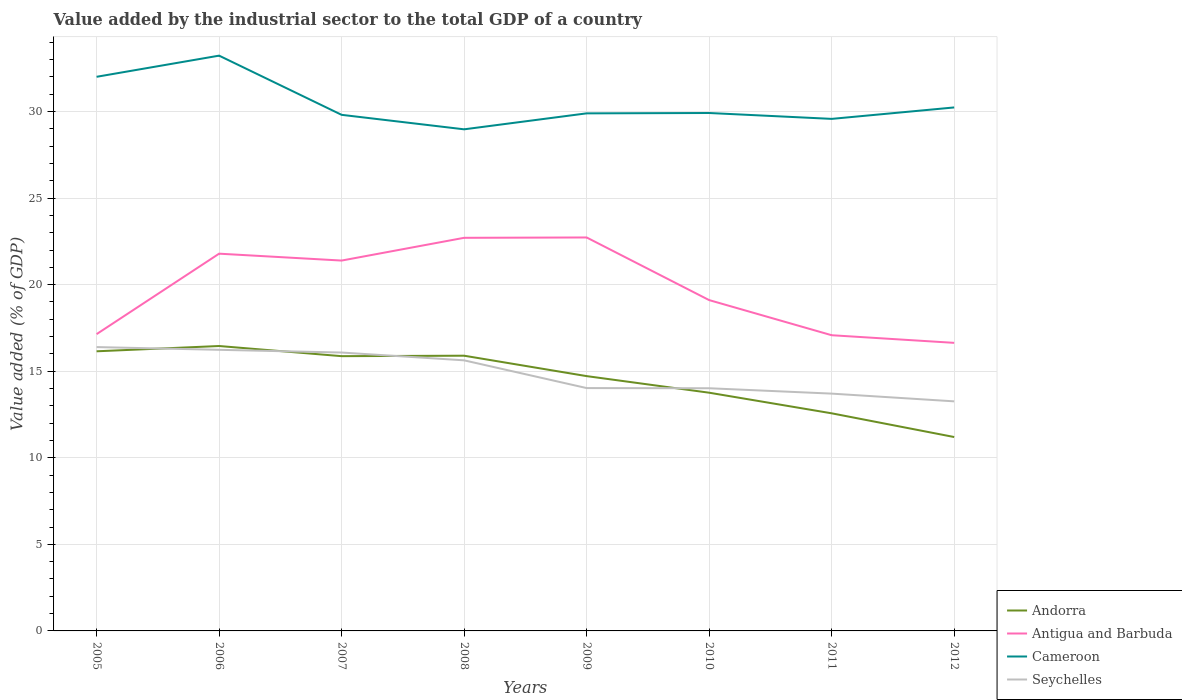Across all years, what is the maximum value added by the industrial sector to the total GDP in Antigua and Barbuda?
Make the answer very short. 16.64. What is the total value added by the industrial sector to the total GDP in Seychelles in the graph?
Provide a succinct answer. 0.31. What is the difference between the highest and the second highest value added by the industrial sector to the total GDP in Andorra?
Make the answer very short. 5.26. How many lines are there?
Give a very brief answer. 4. What is the difference between two consecutive major ticks on the Y-axis?
Ensure brevity in your answer.  5. Are the values on the major ticks of Y-axis written in scientific E-notation?
Keep it short and to the point. No. Does the graph contain grids?
Give a very brief answer. Yes. Where does the legend appear in the graph?
Offer a terse response. Bottom right. How are the legend labels stacked?
Keep it short and to the point. Vertical. What is the title of the graph?
Ensure brevity in your answer.  Value added by the industrial sector to the total GDP of a country. Does "Tuvalu" appear as one of the legend labels in the graph?
Give a very brief answer. No. What is the label or title of the Y-axis?
Your answer should be very brief. Value added (% of GDP). What is the Value added (% of GDP) in Andorra in 2005?
Ensure brevity in your answer.  16.15. What is the Value added (% of GDP) of Antigua and Barbuda in 2005?
Make the answer very short. 17.14. What is the Value added (% of GDP) of Cameroon in 2005?
Make the answer very short. 32.01. What is the Value added (% of GDP) of Seychelles in 2005?
Ensure brevity in your answer.  16.4. What is the Value added (% of GDP) in Andorra in 2006?
Offer a terse response. 16.46. What is the Value added (% of GDP) in Antigua and Barbuda in 2006?
Your answer should be compact. 21.79. What is the Value added (% of GDP) in Cameroon in 2006?
Your answer should be compact. 33.23. What is the Value added (% of GDP) of Seychelles in 2006?
Offer a terse response. 16.24. What is the Value added (% of GDP) of Andorra in 2007?
Provide a succinct answer. 15.87. What is the Value added (% of GDP) in Antigua and Barbuda in 2007?
Offer a terse response. 21.39. What is the Value added (% of GDP) in Cameroon in 2007?
Offer a terse response. 29.81. What is the Value added (% of GDP) in Seychelles in 2007?
Give a very brief answer. 16.08. What is the Value added (% of GDP) in Andorra in 2008?
Offer a terse response. 15.9. What is the Value added (% of GDP) of Antigua and Barbuda in 2008?
Give a very brief answer. 22.71. What is the Value added (% of GDP) of Cameroon in 2008?
Keep it short and to the point. 28.97. What is the Value added (% of GDP) in Seychelles in 2008?
Your answer should be very brief. 15.63. What is the Value added (% of GDP) in Andorra in 2009?
Offer a terse response. 14.72. What is the Value added (% of GDP) in Antigua and Barbuda in 2009?
Offer a very short reply. 22.73. What is the Value added (% of GDP) in Cameroon in 2009?
Offer a very short reply. 29.9. What is the Value added (% of GDP) in Seychelles in 2009?
Give a very brief answer. 14.03. What is the Value added (% of GDP) of Andorra in 2010?
Your answer should be very brief. 13.76. What is the Value added (% of GDP) in Antigua and Barbuda in 2010?
Your answer should be compact. 19.11. What is the Value added (% of GDP) in Cameroon in 2010?
Keep it short and to the point. 29.92. What is the Value added (% of GDP) of Seychelles in 2010?
Ensure brevity in your answer.  14.02. What is the Value added (% of GDP) in Andorra in 2011?
Provide a succinct answer. 12.57. What is the Value added (% of GDP) of Antigua and Barbuda in 2011?
Your answer should be very brief. 17.08. What is the Value added (% of GDP) in Cameroon in 2011?
Keep it short and to the point. 29.58. What is the Value added (% of GDP) of Seychelles in 2011?
Offer a terse response. 13.71. What is the Value added (% of GDP) of Andorra in 2012?
Give a very brief answer. 11.2. What is the Value added (% of GDP) of Antigua and Barbuda in 2012?
Make the answer very short. 16.64. What is the Value added (% of GDP) of Cameroon in 2012?
Your answer should be compact. 30.24. What is the Value added (% of GDP) of Seychelles in 2012?
Make the answer very short. 13.26. Across all years, what is the maximum Value added (% of GDP) in Andorra?
Provide a succinct answer. 16.46. Across all years, what is the maximum Value added (% of GDP) of Antigua and Barbuda?
Offer a very short reply. 22.73. Across all years, what is the maximum Value added (% of GDP) in Cameroon?
Provide a succinct answer. 33.23. Across all years, what is the maximum Value added (% of GDP) of Seychelles?
Offer a very short reply. 16.4. Across all years, what is the minimum Value added (% of GDP) in Andorra?
Your response must be concise. 11.2. Across all years, what is the minimum Value added (% of GDP) of Antigua and Barbuda?
Offer a very short reply. 16.64. Across all years, what is the minimum Value added (% of GDP) in Cameroon?
Offer a terse response. 28.97. Across all years, what is the minimum Value added (% of GDP) of Seychelles?
Ensure brevity in your answer.  13.26. What is the total Value added (% of GDP) of Andorra in the graph?
Your answer should be very brief. 116.63. What is the total Value added (% of GDP) of Antigua and Barbuda in the graph?
Provide a succinct answer. 158.59. What is the total Value added (% of GDP) of Cameroon in the graph?
Ensure brevity in your answer.  243.65. What is the total Value added (% of GDP) in Seychelles in the graph?
Your answer should be compact. 119.36. What is the difference between the Value added (% of GDP) of Andorra in 2005 and that in 2006?
Your answer should be very brief. -0.3. What is the difference between the Value added (% of GDP) in Antigua and Barbuda in 2005 and that in 2006?
Make the answer very short. -4.65. What is the difference between the Value added (% of GDP) in Cameroon in 2005 and that in 2006?
Offer a terse response. -1.22. What is the difference between the Value added (% of GDP) in Seychelles in 2005 and that in 2006?
Make the answer very short. 0.16. What is the difference between the Value added (% of GDP) in Andorra in 2005 and that in 2007?
Provide a succinct answer. 0.28. What is the difference between the Value added (% of GDP) in Antigua and Barbuda in 2005 and that in 2007?
Your answer should be compact. -4.25. What is the difference between the Value added (% of GDP) in Cameroon in 2005 and that in 2007?
Make the answer very short. 2.2. What is the difference between the Value added (% of GDP) in Seychelles in 2005 and that in 2007?
Offer a terse response. 0.32. What is the difference between the Value added (% of GDP) of Andorra in 2005 and that in 2008?
Provide a succinct answer. 0.25. What is the difference between the Value added (% of GDP) in Antigua and Barbuda in 2005 and that in 2008?
Give a very brief answer. -5.56. What is the difference between the Value added (% of GDP) of Cameroon in 2005 and that in 2008?
Make the answer very short. 3.03. What is the difference between the Value added (% of GDP) in Seychelles in 2005 and that in 2008?
Your answer should be very brief. 0.77. What is the difference between the Value added (% of GDP) in Andorra in 2005 and that in 2009?
Keep it short and to the point. 1.43. What is the difference between the Value added (% of GDP) of Antigua and Barbuda in 2005 and that in 2009?
Keep it short and to the point. -5.58. What is the difference between the Value added (% of GDP) of Cameroon in 2005 and that in 2009?
Your answer should be compact. 2.11. What is the difference between the Value added (% of GDP) of Seychelles in 2005 and that in 2009?
Keep it short and to the point. 2.37. What is the difference between the Value added (% of GDP) of Andorra in 2005 and that in 2010?
Provide a short and direct response. 2.39. What is the difference between the Value added (% of GDP) in Antigua and Barbuda in 2005 and that in 2010?
Your answer should be compact. -1.97. What is the difference between the Value added (% of GDP) of Cameroon in 2005 and that in 2010?
Your answer should be compact. 2.09. What is the difference between the Value added (% of GDP) of Seychelles in 2005 and that in 2010?
Give a very brief answer. 2.38. What is the difference between the Value added (% of GDP) of Andorra in 2005 and that in 2011?
Provide a short and direct response. 3.58. What is the difference between the Value added (% of GDP) in Antigua and Barbuda in 2005 and that in 2011?
Provide a succinct answer. 0.06. What is the difference between the Value added (% of GDP) of Cameroon in 2005 and that in 2011?
Your answer should be compact. 2.43. What is the difference between the Value added (% of GDP) of Seychelles in 2005 and that in 2011?
Ensure brevity in your answer.  2.69. What is the difference between the Value added (% of GDP) in Andorra in 2005 and that in 2012?
Ensure brevity in your answer.  4.95. What is the difference between the Value added (% of GDP) of Antigua and Barbuda in 2005 and that in 2012?
Give a very brief answer. 0.5. What is the difference between the Value added (% of GDP) of Cameroon in 2005 and that in 2012?
Your answer should be compact. 1.77. What is the difference between the Value added (% of GDP) of Seychelles in 2005 and that in 2012?
Your response must be concise. 3.14. What is the difference between the Value added (% of GDP) in Andorra in 2006 and that in 2007?
Offer a very short reply. 0.59. What is the difference between the Value added (% of GDP) of Antigua and Barbuda in 2006 and that in 2007?
Provide a succinct answer. 0.4. What is the difference between the Value added (% of GDP) of Cameroon in 2006 and that in 2007?
Offer a terse response. 3.42. What is the difference between the Value added (% of GDP) of Seychelles in 2006 and that in 2007?
Make the answer very short. 0.16. What is the difference between the Value added (% of GDP) in Andorra in 2006 and that in 2008?
Your answer should be very brief. 0.56. What is the difference between the Value added (% of GDP) of Antigua and Barbuda in 2006 and that in 2008?
Make the answer very short. -0.92. What is the difference between the Value added (% of GDP) of Cameroon in 2006 and that in 2008?
Make the answer very short. 4.26. What is the difference between the Value added (% of GDP) of Seychelles in 2006 and that in 2008?
Keep it short and to the point. 0.61. What is the difference between the Value added (% of GDP) of Andorra in 2006 and that in 2009?
Your response must be concise. 1.74. What is the difference between the Value added (% of GDP) in Antigua and Barbuda in 2006 and that in 2009?
Give a very brief answer. -0.94. What is the difference between the Value added (% of GDP) of Cameroon in 2006 and that in 2009?
Give a very brief answer. 3.33. What is the difference between the Value added (% of GDP) of Seychelles in 2006 and that in 2009?
Provide a succinct answer. 2.21. What is the difference between the Value added (% of GDP) of Andorra in 2006 and that in 2010?
Your response must be concise. 2.7. What is the difference between the Value added (% of GDP) of Antigua and Barbuda in 2006 and that in 2010?
Give a very brief answer. 2.68. What is the difference between the Value added (% of GDP) of Cameroon in 2006 and that in 2010?
Keep it short and to the point. 3.31. What is the difference between the Value added (% of GDP) of Seychelles in 2006 and that in 2010?
Provide a succinct answer. 2.22. What is the difference between the Value added (% of GDP) of Andorra in 2006 and that in 2011?
Ensure brevity in your answer.  3.89. What is the difference between the Value added (% of GDP) in Antigua and Barbuda in 2006 and that in 2011?
Provide a succinct answer. 4.71. What is the difference between the Value added (% of GDP) of Cameroon in 2006 and that in 2011?
Provide a short and direct response. 3.65. What is the difference between the Value added (% of GDP) of Seychelles in 2006 and that in 2011?
Your response must be concise. 2.53. What is the difference between the Value added (% of GDP) of Andorra in 2006 and that in 2012?
Provide a succinct answer. 5.26. What is the difference between the Value added (% of GDP) in Antigua and Barbuda in 2006 and that in 2012?
Offer a very short reply. 5.15. What is the difference between the Value added (% of GDP) in Cameroon in 2006 and that in 2012?
Offer a terse response. 2.99. What is the difference between the Value added (% of GDP) in Seychelles in 2006 and that in 2012?
Give a very brief answer. 2.98. What is the difference between the Value added (% of GDP) of Andorra in 2007 and that in 2008?
Offer a very short reply. -0.03. What is the difference between the Value added (% of GDP) in Antigua and Barbuda in 2007 and that in 2008?
Your answer should be compact. -1.31. What is the difference between the Value added (% of GDP) of Cameroon in 2007 and that in 2008?
Provide a succinct answer. 0.84. What is the difference between the Value added (% of GDP) of Seychelles in 2007 and that in 2008?
Offer a very short reply. 0.45. What is the difference between the Value added (% of GDP) in Andorra in 2007 and that in 2009?
Offer a terse response. 1.15. What is the difference between the Value added (% of GDP) in Antigua and Barbuda in 2007 and that in 2009?
Make the answer very short. -1.33. What is the difference between the Value added (% of GDP) in Cameroon in 2007 and that in 2009?
Your answer should be compact. -0.09. What is the difference between the Value added (% of GDP) in Seychelles in 2007 and that in 2009?
Provide a succinct answer. 2.05. What is the difference between the Value added (% of GDP) of Andorra in 2007 and that in 2010?
Ensure brevity in your answer.  2.11. What is the difference between the Value added (% of GDP) in Antigua and Barbuda in 2007 and that in 2010?
Provide a succinct answer. 2.28. What is the difference between the Value added (% of GDP) of Cameroon in 2007 and that in 2010?
Offer a very short reply. -0.11. What is the difference between the Value added (% of GDP) of Seychelles in 2007 and that in 2010?
Keep it short and to the point. 2.06. What is the difference between the Value added (% of GDP) of Andorra in 2007 and that in 2011?
Your answer should be compact. 3.3. What is the difference between the Value added (% of GDP) of Antigua and Barbuda in 2007 and that in 2011?
Make the answer very short. 4.31. What is the difference between the Value added (% of GDP) of Cameroon in 2007 and that in 2011?
Offer a terse response. 0.23. What is the difference between the Value added (% of GDP) of Seychelles in 2007 and that in 2011?
Provide a short and direct response. 2.37. What is the difference between the Value added (% of GDP) in Andorra in 2007 and that in 2012?
Give a very brief answer. 4.67. What is the difference between the Value added (% of GDP) of Antigua and Barbuda in 2007 and that in 2012?
Your answer should be compact. 4.75. What is the difference between the Value added (% of GDP) of Cameroon in 2007 and that in 2012?
Provide a short and direct response. -0.43. What is the difference between the Value added (% of GDP) of Seychelles in 2007 and that in 2012?
Give a very brief answer. 2.82. What is the difference between the Value added (% of GDP) in Andorra in 2008 and that in 2009?
Make the answer very short. 1.18. What is the difference between the Value added (% of GDP) in Antigua and Barbuda in 2008 and that in 2009?
Keep it short and to the point. -0.02. What is the difference between the Value added (% of GDP) of Cameroon in 2008 and that in 2009?
Offer a very short reply. -0.92. What is the difference between the Value added (% of GDP) in Seychelles in 2008 and that in 2009?
Make the answer very short. 1.6. What is the difference between the Value added (% of GDP) of Andorra in 2008 and that in 2010?
Give a very brief answer. 2.14. What is the difference between the Value added (% of GDP) in Antigua and Barbuda in 2008 and that in 2010?
Provide a succinct answer. 3.6. What is the difference between the Value added (% of GDP) of Cameroon in 2008 and that in 2010?
Provide a succinct answer. -0.94. What is the difference between the Value added (% of GDP) in Seychelles in 2008 and that in 2010?
Ensure brevity in your answer.  1.61. What is the difference between the Value added (% of GDP) in Andorra in 2008 and that in 2011?
Your response must be concise. 3.33. What is the difference between the Value added (% of GDP) in Antigua and Barbuda in 2008 and that in 2011?
Your answer should be compact. 5.63. What is the difference between the Value added (% of GDP) in Cameroon in 2008 and that in 2011?
Provide a short and direct response. -0.6. What is the difference between the Value added (% of GDP) in Seychelles in 2008 and that in 2011?
Offer a very short reply. 1.92. What is the difference between the Value added (% of GDP) of Andorra in 2008 and that in 2012?
Offer a very short reply. 4.7. What is the difference between the Value added (% of GDP) in Antigua and Barbuda in 2008 and that in 2012?
Provide a short and direct response. 6.07. What is the difference between the Value added (% of GDP) in Cameroon in 2008 and that in 2012?
Your response must be concise. -1.26. What is the difference between the Value added (% of GDP) of Seychelles in 2008 and that in 2012?
Make the answer very short. 2.37. What is the difference between the Value added (% of GDP) of Andorra in 2009 and that in 2010?
Your answer should be very brief. 0.96. What is the difference between the Value added (% of GDP) in Antigua and Barbuda in 2009 and that in 2010?
Make the answer very short. 3.62. What is the difference between the Value added (% of GDP) of Cameroon in 2009 and that in 2010?
Your response must be concise. -0.02. What is the difference between the Value added (% of GDP) in Seychelles in 2009 and that in 2010?
Offer a very short reply. 0.01. What is the difference between the Value added (% of GDP) of Andorra in 2009 and that in 2011?
Your answer should be very brief. 2.15. What is the difference between the Value added (% of GDP) of Antigua and Barbuda in 2009 and that in 2011?
Make the answer very short. 5.65. What is the difference between the Value added (% of GDP) in Cameroon in 2009 and that in 2011?
Make the answer very short. 0.32. What is the difference between the Value added (% of GDP) of Seychelles in 2009 and that in 2011?
Your response must be concise. 0.32. What is the difference between the Value added (% of GDP) in Andorra in 2009 and that in 2012?
Ensure brevity in your answer.  3.52. What is the difference between the Value added (% of GDP) in Antigua and Barbuda in 2009 and that in 2012?
Your answer should be compact. 6.09. What is the difference between the Value added (% of GDP) of Cameroon in 2009 and that in 2012?
Keep it short and to the point. -0.34. What is the difference between the Value added (% of GDP) of Seychelles in 2009 and that in 2012?
Provide a short and direct response. 0.77. What is the difference between the Value added (% of GDP) of Andorra in 2010 and that in 2011?
Provide a short and direct response. 1.19. What is the difference between the Value added (% of GDP) of Antigua and Barbuda in 2010 and that in 2011?
Offer a very short reply. 2.03. What is the difference between the Value added (% of GDP) of Cameroon in 2010 and that in 2011?
Provide a short and direct response. 0.34. What is the difference between the Value added (% of GDP) of Seychelles in 2010 and that in 2011?
Offer a terse response. 0.31. What is the difference between the Value added (% of GDP) in Andorra in 2010 and that in 2012?
Your answer should be very brief. 2.56. What is the difference between the Value added (% of GDP) in Antigua and Barbuda in 2010 and that in 2012?
Keep it short and to the point. 2.47. What is the difference between the Value added (% of GDP) in Cameroon in 2010 and that in 2012?
Make the answer very short. -0.32. What is the difference between the Value added (% of GDP) of Seychelles in 2010 and that in 2012?
Provide a short and direct response. 0.76. What is the difference between the Value added (% of GDP) of Andorra in 2011 and that in 2012?
Make the answer very short. 1.37. What is the difference between the Value added (% of GDP) in Antigua and Barbuda in 2011 and that in 2012?
Ensure brevity in your answer.  0.44. What is the difference between the Value added (% of GDP) of Cameroon in 2011 and that in 2012?
Provide a short and direct response. -0.66. What is the difference between the Value added (% of GDP) in Seychelles in 2011 and that in 2012?
Your answer should be very brief. 0.45. What is the difference between the Value added (% of GDP) of Andorra in 2005 and the Value added (% of GDP) of Antigua and Barbuda in 2006?
Keep it short and to the point. -5.64. What is the difference between the Value added (% of GDP) of Andorra in 2005 and the Value added (% of GDP) of Cameroon in 2006?
Your response must be concise. -17.08. What is the difference between the Value added (% of GDP) of Andorra in 2005 and the Value added (% of GDP) of Seychelles in 2006?
Your response must be concise. -0.09. What is the difference between the Value added (% of GDP) of Antigua and Barbuda in 2005 and the Value added (% of GDP) of Cameroon in 2006?
Ensure brevity in your answer.  -16.09. What is the difference between the Value added (% of GDP) of Antigua and Barbuda in 2005 and the Value added (% of GDP) of Seychelles in 2006?
Keep it short and to the point. 0.91. What is the difference between the Value added (% of GDP) in Cameroon in 2005 and the Value added (% of GDP) in Seychelles in 2006?
Offer a terse response. 15.77. What is the difference between the Value added (% of GDP) in Andorra in 2005 and the Value added (% of GDP) in Antigua and Barbuda in 2007?
Provide a short and direct response. -5.24. What is the difference between the Value added (% of GDP) of Andorra in 2005 and the Value added (% of GDP) of Cameroon in 2007?
Your response must be concise. -13.66. What is the difference between the Value added (% of GDP) of Andorra in 2005 and the Value added (% of GDP) of Seychelles in 2007?
Keep it short and to the point. 0.07. What is the difference between the Value added (% of GDP) of Antigua and Barbuda in 2005 and the Value added (% of GDP) of Cameroon in 2007?
Ensure brevity in your answer.  -12.67. What is the difference between the Value added (% of GDP) in Antigua and Barbuda in 2005 and the Value added (% of GDP) in Seychelles in 2007?
Your response must be concise. 1.06. What is the difference between the Value added (% of GDP) in Cameroon in 2005 and the Value added (% of GDP) in Seychelles in 2007?
Offer a very short reply. 15.93. What is the difference between the Value added (% of GDP) of Andorra in 2005 and the Value added (% of GDP) of Antigua and Barbuda in 2008?
Your answer should be compact. -6.56. What is the difference between the Value added (% of GDP) of Andorra in 2005 and the Value added (% of GDP) of Cameroon in 2008?
Offer a terse response. -12.82. What is the difference between the Value added (% of GDP) of Andorra in 2005 and the Value added (% of GDP) of Seychelles in 2008?
Offer a terse response. 0.52. What is the difference between the Value added (% of GDP) in Antigua and Barbuda in 2005 and the Value added (% of GDP) in Cameroon in 2008?
Offer a terse response. -11.83. What is the difference between the Value added (% of GDP) of Antigua and Barbuda in 2005 and the Value added (% of GDP) of Seychelles in 2008?
Make the answer very short. 1.51. What is the difference between the Value added (% of GDP) of Cameroon in 2005 and the Value added (% of GDP) of Seychelles in 2008?
Your response must be concise. 16.38. What is the difference between the Value added (% of GDP) of Andorra in 2005 and the Value added (% of GDP) of Antigua and Barbuda in 2009?
Your answer should be very brief. -6.57. What is the difference between the Value added (% of GDP) of Andorra in 2005 and the Value added (% of GDP) of Cameroon in 2009?
Keep it short and to the point. -13.74. What is the difference between the Value added (% of GDP) in Andorra in 2005 and the Value added (% of GDP) in Seychelles in 2009?
Give a very brief answer. 2.12. What is the difference between the Value added (% of GDP) in Antigua and Barbuda in 2005 and the Value added (% of GDP) in Cameroon in 2009?
Ensure brevity in your answer.  -12.75. What is the difference between the Value added (% of GDP) of Antigua and Barbuda in 2005 and the Value added (% of GDP) of Seychelles in 2009?
Provide a succinct answer. 3.12. What is the difference between the Value added (% of GDP) of Cameroon in 2005 and the Value added (% of GDP) of Seychelles in 2009?
Give a very brief answer. 17.98. What is the difference between the Value added (% of GDP) of Andorra in 2005 and the Value added (% of GDP) of Antigua and Barbuda in 2010?
Make the answer very short. -2.96. What is the difference between the Value added (% of GDP) of Andorra in 2005 and the Value added (% of GDP) of Cameroon in 2010?
Ensure brevity in your answer.  -13.76. What is the difference between the Value added (% of GDP) of Andorra in 2005 and the Value added (% of GDP) of Seychelles in 2010?
Ensure brevity in your answer.  2.13. What is the difference between the Value added (% of GDP) in Antigua and Barbuda in 2005 and the Value added (% of GDP) in Cameroon in 2010?
Your answer should be compact. -12.77. What is the difference between the Value added (% of GDP) of Antigua and Barbuda in 2005 and the Value added (% of GDP) of Seychelles in 2010?
Ensure brevity in your answer.  3.13. What is the difference between the Value added (% of GDP) in Cameroon in 2005 and the Value added (% of GDP) in Seychelles in 2010?
Give a very brief answer. 17.99. What is the difference between the Value added (% of GDP) in Andorra in 2005 and the Value added (% of GDP) in Antigua and Barbuda in 2011?
Your answer should be compact. -0.93. What is the difference between the Value added (% of GDP) of Andorra in 2005 and the Value added (% of GDP) of Cameroon in 2011?
Offer a very short reply. -13.43. What is the difference between the Value added (% of GDP) of Andorra in 2005 and the Value added (% of GDP) of Seychelles in 2011?
Offer a terse response. 2.44. What is the difference between the Value added (% of GDP) in Antigua and Barbuda in 2005 and the Value added (% of GDP) in Cameroon in 2011?
Your response must be concise. -12.43. What is the difference between the Value added (% of GDP) in Antigua and Barbuda in 2005 and the Value added (% of GDP) in Seychelles in 2011?
Ensure brevity in your answer.  3.44. What is the difference between the Value added (% of GDP) in Cameroon in 2005 and the Value added (% of GDP) in Seychelles in 2011?
Give a very brief answer. 18.3. What is the difference between the Value added (% of GDP) in Andorra in 2005 and the Value added (% of GDP) in Antigua and Barbuda in 2012?
Offer a terse response. -0.49. What is the difference between the Value added (% of GDP) in Andorra in 2005 and the Value added (% of GDP) in Cameroon in 2012?
Offer a terse response. -14.09. What is the difference between the Value added (% of GDP) in Andorra in 2005 and the Value added (% of GDP) in Seychelles in 2012?
Make the answer very short. 2.89. What is the difference between the Value added (% of GDP) of Antigua and Barbuda in 2005 and the Value added (% of GDP) of Cameroon in 2012?
Provide a succinct answer. -13.09. What is the difference between the Value added (% of GDP) in Antigua and Barbuda in 2005 and the Value added (% of GDP) in Seychelles in 2012?
Give a very brief answer. 3.88. What is the difference between the Value added (% of GDP) of Cameroon in 2005 and the Value added (% of GDP) of Seychelles in 2012?
Your response must be concise. 18.75. What is the difference between the Value added (% of GDP) in Andorra in 2006 and the Value added (% of GDP) in Antigua and Barbuda in 2007?
Keep it short and to the point. -4.94. What is the difference between the Value added (% of GDP) in Andorra in 2006 and the Value added (% of GDP) in Cameroon in 2007?
Provide a succinct answer. -13.35. What is the difference between the Value added (% of GDP) in Andorra in 2006 and the Value added (% of GDP) in Seychelles in 2007?
Give a very brief answer. 0.38. What is the difference between the Value added (% of GDP) of Antigua and Barbuda in 2006 and the Value added (% of GDP) of Cameroon in 2007?
Provide a succinct answer. -8.02. What is the difference between the Value added (% of GDP) in Antigua and Barbuda in 2006 and the Value added (% of GDP) in Seychelles in 2007?
Keep it short and to the point. 5.71. What is the difference between the Value added (% of GDP) of Cameroon in 2006 and the Value added (% of GDP) of Seychelles in 2007?
Provide a short and direct response. 17.15. What is the difference between the Value added (% of GDP) in Andorra in 2006 and the Value added (% of GDP) in Antigua and Barbuda in 2008?
Keep it short and to the point. -6.25. What is the difference between the Value added (% of GDP) of Andorra in 2006 and the Value added (% of GDP) of Cameroon in 2008?
Your response must be concise. -12.52. What is the difference between the Value added (% of GDP) of Andorra in 2006 and the Value added (% of GDP) of Seychelles in 2008?
Your answer should be very brief. 0.83. What is the difference between the Value added (% of GDP) of Antigua and Barbuda in 2006 and the Value added (% of GDP) of Cameroon in 2008?
Your answer should be very brief. -7.18. What is the difference between the Value added (% of GDP) in Antigua and Barbuda in 2006 and the Value added (% of GDP) in Seychelles in 2008?
Ensure brevity in your answer.  6.16. What is the difference between the Value added (% of GDP) of Cameroon in 2006 and the Value added (% of GDP) of Seychelles in 2008?
Make the answer very short. 17.6. What is the difference between the Value added (% of GDP) in Andorra in 2006 and the Value added (% of GDP) in Antigua and Barbuda in 2009?
Your answer should be very brief. -6.27. What is the difference between the Value added (% of GDP) in Andorra in 2006 and the Value added (% of GDP) in Cameroon in 2009?
Give a very brief answer. -13.44. What is the difference between the Value added (% of GDP) of Andorra in 2006 and the Value added (% of GDP) of Seychelles in 2009?
Your answer should be compact. 2.43. What is the difference between the Value added (% of GDP) of Antigua and Barbuda in 2006 and the Value added (% of GDP) of Cameroon in 2009?
Offer a very short reply. -8.11. What is the difference between the Value added (% of GDP) in Antigua and Barbuda in 2006 and the Value added (% of GDP) in Seychelles in 2009?
Ensure brevity in your answer.  7.76. What is the difference between the Value added (% of GDP) in Cameroon in 2006 and the Value added (% of GDP) in Seychelles in 2009?
Your response must be concise. 19.2. What is the difference between the Value added (% of GDP) of Andorra in 2006 and the Value added (% of GDP) of Antigua and Barbuda in 2010?
Keep it short and to the point. -2.65. What is the difference between the Value added (% of GDP) in Andorra in 2006 and the Value added (% of GDP) in Cameroon in 2010?
Provide a short and direct response. -13.46. What is the difference between the Value added (% of GDP) in Andorra in 2006 and the Value added (% of GDP) in Seychelles in 2010?
Your response must be concise. 2.44. What is the difference between the Value added (% of GDP) of Antigua and Barbuda in 2006 and the Value added (% of GDP) of Cameroon in 2010?
Ensure brevity in your answer.  -8.13. What is the difference between the Value added (% of GDP) in Antigua and Barbuda in 2006 and the Value added (% of GDP) in Seychelles in 2010?
Keep it short and to the point. 7.77. What is the difference between the Value added (% of GDP) of Cameroon in 2006 and the Value added (% of GDP) of Seychelles in 2010?
Give a very brief answer. 19.21. What is the difference between the Value added (% of GDP) of Andorra in 2006 and the Value added (% of GDP) of Antigua and Barbuda in 2011?
Provide a succinct answer. -0.62. What is the difference between the Value added (% of GDP) in Andorra in 2006 and the Value added (% of GDP) in Cameroon in 2011?
Your response must be concise. -13.12. What is the difference between the Value added (% of GDP) of Andorra in 2006 and the Value added (% of GDP) of Seychelles in 2011?
Ensure brevity in your answer.  2.75. What is the difference between the Value added (% of GDP) in Antigua and Barbuda in 2006 and the Value added (% of GDP) in Cameroon in 2011?
Your answer should be compact. -7.79. What is the difference between the Value added (% of GDP) in Antigua and Barbuda in 2006 and the Value added (% of GDP) in Seychelles in 2011?
Provide a short and direct response. 8.08. What is the difference between the Value added (% of GDP) of Cameroon in 2006 and the Value added (% of GDP) of Seychelles in 2011?
Provide a succinct answer. 19.52. What is the difference between the Value added (% of GDP) in Andorra in 2006 and the Value added (% of GDP) in Antigua and Barbuda in 2012?
Offer a very short reply. -0.18. What is the difference between the Value added (% of GDP) of Andorra in 2006 and the Value added (% of GDP) of Cameroon in 2012?
Make the answer very short. -13.78. What is the difference between the Value added (% of GDP) in Andorra in 2006 and the Value added (% of GDP) in Seychelles in 2012?
Give a very brief answer. 3.2. What is the difference between the Value added (% of GDP) in Antigua and Barbuda in 2006 and the Value added (% of GDP) in Cameroon in 2012?
Give a very brief answer. -8.45. What is the difference between the Value added (% of GDP) of Antigua and Barbuda in 2006 and the Value added (% of GDP) of Seychelles in 2012?
Ensure brevity in your answer.  8.53. What is the difference between the Value added (% of GDP) in Cameroon in 2006 and the Value added (% of GDP) in Seychelles in 2012?
Keep it short and to the point. 19.97. What is the difference between the Value added (% of GDP) in Andorra in 2007 and the Value added (% of GDP) in Antigua and Barbuda in 2008?
Give a very brief answer. -6.84. What is the difference between the Value added (% of GDP) in Andorra in 2007 and the Value added (% of GDP) in Cameroon in 2008?
Provide a succinct answer. -13.1. What is the difference between the Value added (% of GDP) of Andorra in 2007 and the Value added (% of GDP) of Seychelles in 2008?
Make the answer very short. 0.24. What is the difference between the Value added (% of GDP) of Antigua and Barbuda in 2007 and the Value added (% of GDP) of Cameroon in 2008?
Your answer should be very brief. -7.58. What is the difference between the Value added (% of GDP) in Antigua and Barbuda in 2007 and the Value added (% of GDP) in Seychelles in 2008?
Ensure brevity in your answer.  5.76. What is the difference between the Value added (% of GDP) of Cameroon in 2007 and the Value added (% of GDP) of Seychelles in 2008?
Ensure brevity in your answer.  14.18. What is the difference between the Value added (% of GDP) of Andorra in 2007 and the Value added (% of GDP) of Antigua and Barbuda in 2009?
Offer a very short reply. -6.86. What is the difference between the Value added (% of GDP) in Andorra in 2007 and the Value added (% of GDP) in Cameroon in 2009?
Provide a short and direct response. -14.03. What is the difference between the Value added (% of GDP) of Andorra in 2007 and the Value added (% of GDP) of Seychelles in 2009?
Your answer should be very brief. 1.84. What is the difference between the Value added (% of GDP) of Antigua and Barbuda in 2007 and the Value added (% of GDP) of Cameroon in 2009?
Make the answer very short. -8.5. What is the difference between the Value added (% of GDP) of Antigua and Barbuda in 2007 and the Value added (% of GDP) of Seychelles in 2009?
Make the answer very short. 7.37. What is the difference between the Value added (% of GDP) in Cameroon in 2007 and the Value added (% of GDP) in Seychelles in 2009?
Keep it short and to the point. 15.78. What is the difference between the Value added (% of GDP) of Andorra in 2007 and the Value added (% of GDP) of Antigua and Barbuda in 2010?
Keep it short and to the point. -3.24. What is the difference between the Value added (% of GDP) of Andorra in 2007 and the Value added (% of GDP) of Cameroon in 2010?
Your answer should be very brief. -14.05. What is the difference between the Value added (% of GDP) of Andorra in 2007 and the Value added (% of GDP) of Seychelles in 2010?
Offer a very short reply. 1.85. What is the difference between the Value added (% of GDP) of Antigua and Barbuda in 2007 and the Value added (% of GDP) of Cameroon in 2010?
Give a very brief answer. -8.52. What is the difference between the Value added (% of GDP) in Antigua and Barbuda in 2007 and the Value added (% of GDP) in Seychelles in 2010?
Give a very brief answer. 7.38. What is the difference between the Value added (% of GDP) of Cameroon in 2007 and the Value added (% of GDP) of Seychelles in 2010?
Offer a terse response. 15.79. What is the difference between the Value added (% of GDP) of Andorra in 2007 and the Value added (% of GDP) of Antigua and Barbuda in 2011?
Provide a succinct answer. -1.21. What is the difference between the Value added (% of GDP) in Andorra in 2007 and the Value added (% of GDP) in Cameroon in 2011?
Offer a terse response. -13.71. What is the difference between the Value added (% of GDP) in Andorra in 2007 and the Value added (% of GDP) in Seychelles in 2011?
Your response must be concise. 2.16. What is the difference between the Value added (% of GDP) in Antigua and Barbuda in 2007 and the Value added (% of GDP) in Cameroon in 2011?
Offer a terse response. -8.18. What is the difference between the Value added (% of GDP) in Antigua and Barbuda in 2007 and the Value added (% of GDP) in Seychelles in 2011?
Your response must be concise. 7.69. What is the difference between the Value added (% of GDP) of Cameroon in 2007 and the Value added (% of GDP) of Seychelles in 2011?
Offer a very short reply. 16.1. What is the difference between the Value added (% of GDP) in Andorra in 2007 and the Value added (% of GDP) in Antigua and Barbuda in 2012?
Keep it short and to the point. -0.77. What is the difference between the Value added (% of GDP) in Andorra in 2007 and the Value added (% of GDP) in Cameroon in 2012?
Your response must be concise. -14.37. What is the difference between the Value added (% of GDP) of Andorra in 2007 and the Value added (% of GDP) of Seychelles in 2012?
Offer a terse response. 2.61. What is the difference between the Value added (% of GDP) of Antigua and Barbuda in 2007 and the Value added (% of GDP) of Cameroon in 2012?
Your response must be concise. -8.85. What is the difference between the Value added (% of GDP) of Antigua and Barbuda in 2007 and the Value added (% of GDP) of Seychelles in 2012?
Give a very brief answer. 8.13. What is the difference between the Value added (% of GDP) of Cameroon in 2007 and the Value added (% of GDP) of Seychelles in 2012?
Provide a short and direct response. 16.55. What is the difference between the Value added (% of GDP) in Andorra in 2008 and the Value added (% of GDP) in Antigua and Barbuda in 2009?
Your answer should be compact. -6.83. What is the difference between the Value added (% of GDP) of Andorra in 2008 and the Value added (% of GDP) of Cameroon in 2009?
Give a very brief answer. -14. What is the difference between the Value added (% of GDP) in Andorra in 2008 and the Value added (% of GDP) in Seychelles in 2009?
Offer a terse response. 1.87. What is the difference between the Value added (% of GDP) of Antigua and Barbuda in 2008 and the Value added (% of GDP) of Cameroon in 2009?
Give a very brief answer. -7.19. What is the difference between the Value added (% of GDP) of Antigua and Barbuda in 2008 and the Value added (% of GDP) of Seychelles in 2009?
Keep it short and to the point. 8.68. What is the difference between the Value added (% of GDP) of Cameroon in 2008 and the Value added (% of GDP) of Seychelles in 2009?
Ensure brevity in your answer.  14.95. What is the difference between the Value added (% of GDP) of Andorra in 2008 and the Value added (% of GDP) of Antigua and Barbuda in 2010?
Your response must be concise. -3.21. What is the difference between the Value added (% of GDP) in Andorra in 2008 and the Value added (% of GDP) in Cameroon in 2010?
Ensure brevity in your answer.  -14.02. What is the difference between the Value added (% of GDP) in Andorra in 2008 and the Value added (% of GDP) in Seychelles in 2010?
Your response must be concise. 1.88. What is the difference between the Value added (% of GDP) of Antigua and Barbuda in 2008 and the Value added (% of GDP) of Cameroon in 2010?
Make the answer very short. -7.21. What is the difference between the Value added (% of GDP) in Antigua and Barbuda in 2008 and the Value added (% of GDP) in Seychelles in 2010?
Offer a very short reply. 8.69. What is the difference between the Value added (% of GDP) in Cameroon in 2008 and the Value added (% of GDP) in Seychelles in 2010?
Make the answer very short. 14.96. What is the difference between the Value added (% of GDP) of Andorra in 2008 and the Value added (% of GDP) of Antigua and Barbuda in 2011?
Your response must be concise. -1.18. What is the difference between the Value added (% of GDP) in Andorra in 2008 and the Value added (% of GDP) in Cameroon in 2011?
Ensure brevity in your answer.  -13.68. What is the difference between the Value added (% of GDP) in Andorra in 2008 and the Value added (% of GDP) in Seychelles in 2011?
Your response must be concise. 2.19. What is the difference between the Value added (% of GDP) of Antigua and Barbuda in 2008 and the Value added (% of GDP) of Cameroon in 2011?
Your answer should be compact. -6.87. What is the difference between the Value added (% of GDP) of Antigua and Barbuda in 2008 and the Value added (% of GDP) of Seychelles in 2011?
Keep it short and to the point. 9. What is the difference between the Value added (% of GDP) in Cameroon in 2008 and the Value added (% of GDP) in Seychelles in 2011?
Provide a succinct answer. 15.27. What is the difference between the Value added (% of GDP) of Andorra in 2008 and the Value added (% of GDP) of Antigua and Barbuda in 2012?
Your answer should be very brief. -0.74. What is the difference between the Value added (% of GDP) of Andorra in 2008 and the Value added (% of GDP) of Cameroon in 2012?
Give a very brief answer. -14.34. What is the difference between the Value added (% of GDP) in Andorra in 2008 and the Value added (% of GDP) in Seychelles in 2012?
Keep it short and to the point. 2.64. What is the difference between the Value added (% of GDP) of Antigua and Barbuda in 2008 and the Value added (% of GDP) of Cameroon in 2012?
Ensure brevity in your answer.  -7.53. What is the difference between the Value added (% of GDP) in Antigua and Barbuda in 2008 and the Value added (% of GDP) in Seychelles in 2012?
Keep it short and to the point. 9.45. What is the difference between the Value added (% of GDP) of Cameroon in 2008 and the Value added (% of GDP) of Seychelles in 2012?
Offer a very short reply. 15.71. What is the difference between the Value added (% of GDP) in Andorra in 2009 and the Value added (% of GDP) in Antigua and Barbuda in 2010?
Make the answer very short. -4.39. What is the difference between the Value added (% of GDP) of Andorra in 2009 and the Value added (% of GDP) of Cameroon in 2010?
Provide a short and direct response. -15.2. What is the difference between the Value added (% of GDP) of Andorra in 2009 and the Value added (% of GDP) of Seychelles in 2010?
Offer a terse response. 0.7. What is the difference between the Value added (% of GDP) of Antigua and Barbuda in 2009 and the Value added (% of GDP) of Cameroon in 2010?
Offer a terse response. -7.19. What is the difference between the Value added (% of GDP) in Antigua and Barbuda in 2009 and the Value added (% of GDP) in Seychelles in 2010?
Provide a short and direct response. 8.71. What is the difference between the Value added (% of GDP) of Cameroon in 2009 and the Value added (% of GDP) of Seychelles in 2010?
Provide a short and direct response. 15.88. What is the difference between the Value added (% of GDP) in Andorra in 2009 and the Value added (% of GDP) in Antigua and Barbuda in 2011?
Give a very brief answer. -2.36. What is the difference between the Value added (% of GDP) of Andorra in 2009 and the Value added (% of GDP) of Cameroon in 2011?
Offer a terse response. -14.86. What is the difference between the Value added (% of GDP) in Andorra in 2009 and the Value added (% of GDP) in Seychelles in 2011?
Your answer should be very brief. 1.01. What is the difference between the Value added (% of GDP) in Antigua and Barbuda in 2009 and the Value added (% of GDP) in Cameroon in 2011?
Provide a succinct answer. -6.85. What is the difference between the Value added (% of GDP) in Antigua and Barbuda in 2009 and the Value added (% of GDP) in Seychelles in 2011?
Keep it short and to the point. 9.02. What is the difference between the Value added (% of GDP) in Cameroon in 2009 and the Value added (% of GDP) in Seychelles in 2011?
Make the answer very short. 16.19. What is the difference between the Value added (% of GDP) in Andorra in 2009 and the Value added (% of GDP) in Antigua and Barbuda in 2012?
Provide a short and direct response. -1.92. What is the difference between the Value added (% of GDP) of Andorra in 2009 and the Value added (% of GDP) of Cameroon in 2012?
Provide a short and direct response. -15.52. What is the difference between the Value added (% of GDP) of Andorra in 2009 and the Value added (% of GDP) of Seychelles in 2012?
Keep it short and to the point. 1.46. What is the difference between the Value added (% of GDP) in Antigua and Barbuda in 2009 and the Value added (% of GDP) in Cameroon in 2012?
Your response must be concise. -7.51. What is the difference between the Value added (% of GDP) of Antigua and Barbuda in 2009 and the Value added (% of GDP) of Seychelles in 2012?
Provide a short and direct response. 9.47. What is the difference between the Value added (% of GDP) in Cameroon in 2009 and the Value added (% of GDP) in Seychelles in 2012?
Keep it short and to the point. 16.64. What is the difference between the Value added (% of GDP) in Andorra in 2010 and the Value added (% of GDP) in Antigua and Barbuda in 2011?
Make the answer very short. -3.32. What is the difference between the Value added (% of GDP) of Andorra in 2010 and the Value added (% of GDP) of Cameroon in 2011?
Your answer should be compact. -15.82. What is the difference between the Value added (% of GDP) of Andorra in 2010 and the Value added (% of GDP) of Seychelles in 2011?
Make the answer very short. 0.05. What is the difference between the Value added (% of GDP) of Antigua and Barbuda in 2010 and the Value added (% of GDP) of Cameroon in 2011?
Your answer should be compact. -10.47. What is the difference between the Value added (% of GDP) of Antigua and Barbuda in 2010 and the Value added (% of GDP) of Seychelles in 2011?
Make the answer very short. 5.4. What is the difference between the Value added (% of GDP) in Cameroon in 2010 and the Value added (% of GDP) in Seychelles in 2011?
Your answer should be compact. 16.21. What is the difference between the Value added (% of GDP) of Andorra in 2010 and the Value added (% of GDP) of Antigua and Barbuda in 2012?
Give a very brief answer. -2.88. What is the difference between the Value added (% of GDP) of Andorra in 2010 and the Value added (% of GDP) of Cameroon in 2012?
Your answer should be compact. -16.48. What is the difference between the Value added (% of GDP) in Andorra in 2010 and the Value added (% of GDP) in Seychelles in 2012?
Keep it short and to the point. 0.5. What is the difference between the Value added (% of GDP) in Antigua and Barbuda in 2010 and the Value added (% of GDP) in Cameroon in 2012?
Your response must be concise. -11.13. What is the difference between the Value added (% of GDP) of Antigua and Barbuda in 2010 and the Value added (% of GDP) of Seychelles in 2012?
Your answer should be very brief. 5.85. What is the difference between the Value added (% of GDP) of Cameroon in 2010 and the Value added (% of GDP) of Seychelles in 2012?
Keep it short and to the point. 16.66. What is the difference between the Value added (% of GDP) in Andorra in 2011 and the Value added (% of GDP) in Antigua and Barbuda in 2012?
Your answer should be very brief. -4.07. What is the difference between the Value added (% of GDP) of Andorra in 2011 and the Value added (% of GDP) of Cameroon in 2012?
Your answer should be very brief. -17.67. What is the difference between the Value added (% of GDP) of Andorra in 2011 and the Value added (% of GDP) of Seychelles in 2012?
Your answer should be compact. -0.69. What is the difference between the Value added (% of GDP) in Antigua and Barbuda in 2011 and the Value added (% of GDP) in Cameroon in 2012?
Your answer should be compact. -13.16. What is the difference between the Value added (% of GDP) of Antigua and Barbuda in 2011 and the Value added (% of GDP) of Seychelles in 2012?
Provide a succinct answer. 3.82. What is the difference between the Value added (% of GDP) of Cameroon in 2011 and the Value added (% of GDP) of Seychelles in 2012?
Make the answer very short. 16.32. What is the average Value added (% of GDP) in Andorra per year?
Provide a succinct answer. 14.58. What is the average Value added (% of GDP) in Antigua and Barbuda per year?
Your answer should be very brief. 19.82. What is the average Value added (% of GDP) in Cameroon per year?
Provide a short and direct response. 30.46. What is the average Value added (% of GDP) of Seychelles per year?
Your answer should be compact. 14.92. In the year 2005, what is the difference between the Value added (% of GDP) in Andorra and Value added (% of GDP) in Antigua and Barbuda?
Your response must be concise. -0.99. In the year 2005, what is the difference between the Value added (% of GDP) of Andorra and Value added (% of GDP) of Cameroon?
Offer a terse response. -15.86. In the year 2005, what is the difference between the Value added (% of GDP) in Andorra and Value added (% of GDP) in Seychelles?
Keep it short and to the point. -0.24. In the year 2005, what is the difference between the Value added (% of GDP) of Antigua and Barbuda and Value added (% of GDP) of Cameroon?
Provide a short and direct response. -14.86. In the year 2005, what is the difference between the Value added (% of GDP) in Antigua and Barbuda and Value added (% of GDP) in Seychelles?
Keep it short and to the point. 0.75. In the year 2005, what is the difference between the Value added (% of GDP) of Cameroon and Value added (% of GDP) of Seychelles?
Make the answer very short. 15.61. In the year 2006, what is the difference between the Value added (% of GDP) in Andorra and Value added (% of GDP) in Antigua and Barbuda?
Your answer should be very brief. -5.33. In the year 2006, what is the difference between the Value added (% of GDP) in Andorra and Value added (% of GDP) in Cameroon?
Provide a succinct answer. -16.77. In the year 2006, what is the difference between the Value added (% of GDP) of Andorra and Value added (% of GDP) of Seychelles?
Ensure brevity in your answer.  0.22. In the year 2006, what is the difference between the Value added (% of GDP) in Antigua and Barbuda and Value added (% of GDP) in Cameroon?
Offer a very short reply. -11.44. In the year 2006, what is the difference between the Value added (% of GDP) of Antigua and Barbuda and Value added (% of GDP) of Seychelles?
Make the answer very short. 5.55. In the year 2006, what is the difference between the Value added (% of GDP) of Cameroon and Value added (% of GDP) of Seychelles?
Keep it short and to the point. 16.99. In the year 2007, what is the difference between the Value added (% of GDP) in Andorra and Value added (% of GDP) in Antigua and Barbuda?
Your answer should be very brief. -5.52. In the year 2007, what is the difference between the Value added (% of GDP) of Andorra and Value added (% of GDP) of Cameroon?
Provide a short and direct response. -13.94. In the year 2007, what is the difference between the Value added (% of GDP) in Andorra and Value added (% of GDP) in Seychelles?
Offer a very short reply. -0.21. In the year 2007, what is the difference between the Value added (% of GDP) in Antigua and Barbuda and Value added (% of GDP) in Cameroon?
Your response must be concise. -8.42. In the year 2007, what is the difference between the Value added (% of GDP) in Antigua and Barbuda and Value added (% of GDP) in Seychelles?
Offer a terse response. 5.31. In the year 2007, what is the difference between the Value added (% of GDP) in Cameroon and Value added (% of GDP) in Seychelles?
Your answer should be compact. 13.73. In the year 2008, what is the difference between the Value added (% of GDP) of Andorra and Value added (% of GDP) of Antigua and Barbuda?
Your response must be concise. -6.81. In the year 2008, what is the difference between the Value added (% of GDP) in Andorra and Value added (% of GDP) in Cameroon?
Make the answer very short. -13.08. In the year 2008, what is the difference between the Value added (% of GDP) in Andorra and Value added (% of GDP) in Seychelles?
Ensure brevity in your answer.  0.27. In the year 2008, what is the difference between the Value added (% of GDP) of Antigua and Barbuda and Value added (% of GDP) of Cameroon?
Ensure brevity in your answer.  -6.27. In the year 2008, what is the difference between the Value added (% of GDP) in Antigua and Barbuda and Value added (% of GDP) in Seychelles?
Provide a succinct answer. 7.08. In the year 2008, what is the difference between the Value added (% of GDP) of Cameroon and Value added (% of GDP) of Seychelles?
Offer a terse response. 13.34. In the year 2009, what is the difference between the Value added (% of GDP) in Andorra and Value added (% of GDP) in Antigua and Barbuda?
Offer a very short reply. -8.01. In the year 2009, what is the difference between the Value added (% of GDP) in Andorra and Value added (% of GDP) in Cameroon?
Offer a terse response. -15.18. In the year 2009, what is the difference between the Value added (% of GDP) of Andorra and Value added (% of GDP) of Seychelles?
Your response must be concise. 0.69. In the year 2009, what is the difference between the Value added (% of GDP) in Antigua and Barbuda and Value added (% of GDP) in Cameroon?
Provide a short and direct response. -7.17. In the year 2009, what is the difference between the Value added (% of GDP) in Antigua and Barbuda and Value added (% of GDP) in Seychelles?
Your answer should be very brief. 8.7. In the year 2009, what is the difference between the Value added (% of GDP) of Cameroon and Value added (% of GDP) of Seychelles?
Your answer should be compact. 15.87. In the year 2010, what is the difference between the Value added (% of GDP) of Andorra and Value added (% of GDP) of Antigua and Barbuda?
Your response must be concise. -5.35. In the year 2010, what is the difference between the Value added (% of GDP) of Andorra and Value added (% of GDP) of Cameroon?
Your answer should be very brief. -16.16. In the year 2010, what is the difference between the Value added (% of GDP) in Andorra and Value added (% of GDP) in Seychelles?
Make the answer very short. -0.26. In the year 2010, what is the difference between the Value added (% of GDP) in Antigua and Barbuda and Value added (% of GDP) in Cameroon?
Provide a short and direct response. -10.81. In the year 2010, what is the difference between the Value added (% of GDP) of Antigua and Barbuda and Value added (% of GDP) of Seychelles?
Keep it short and to the point. 5.09. In the year 2010, what is the difference between the Value added (% of GDP) of Cameroon and Value added (% of GDP) of Seychelles?
Your answer should be very brief. 15.9. In the year 2011, what is the difference between the Value added (% of GDP) of Andorra and Value added (% of GDP) of Antigua and Barbuda?
Provide a short and direct response. -4.51. In the year 2011, what is the difference between the Value added (% of GDP) of Andorra and Value added (% of GDP) of Cameroon?
Ensure brevity in your answer.  -17.01. In the year 2011, what is the difference between the Value added (% of GDP) in Andorra and Value added (% of GDP) in Seychelles?
Provide a succinct answer. -1.14. In the year 2011, what is the difference between the Value added (% of GDP) of Antigua and Barbuda and Value added (% of GDP) of Cameroon?
Keep it short and to the point. -12.5. In the year 2011, what is the difference between the Value added (% of GDP) in Antigua and Barbuda and Value added (% of GDP) in Seychelles?
Your response must be concise. 3.37. In the year 2011, what is the difference between the Value added (% of GDP) of Cameroon and Value added (% of GDP) of Seychelles?
Give a very brief answer. 15.87. In the year 2012, what is the difference between the Value added (% of GDP) in Andorra and Value added (% of GDP) in Antigua and Barbuda?
Your answer should be compact. -5.44. In the year 2012, what is the difference between the Value added (% of GDP) of Andorra and Value added (% of GDP) of Cameroon?
Your answer should be very brief. -19.04. In the year 2012, what is the difference between the Value added (% of GDP) of Andorra and Value added (% of GDP) of Seychelles?
Keep it short and to the point. -2.06. In the year 2012, what is the difference between the Value added (% of GDP) in Antigua and Barbuda and Value added (% of GDP) in Cameroon?
Offer a terse response. -13.6. In the year 2012, what is the difference between the Value added (% of GDP) of Antigua and Barbuda and Value added (% of GDP) of Seychelles?
Provide a short and direct response. 3.38. In the year 2012, what is the difference between the Value added (% of GDP) of Cameroon and Value added (% of GDP) of Seychelles?
Offer a terse response. 16.98. What is the ratio of the Value added (% of GDP) in Andorra in 2005 to that in 2006?
Your response must be concise. 0.98. What is the ratio of the Value added (% of GDP) of Antigua and Barbuda in 2005 to that in 2006?
Offer a terse response. 0.79. What is the ratio of the Value added (% of GDP) in Cameroon in 2005 to that in 2006?
Offer a terse response. 0.96. What is the ratio of the Value added (% of GDP) in Seychelles in 2005 to that in 2006?
Provide a succinct answer. 1.01. What is the ratio of the Value added (% of GDP) of Andorra in 2005 to that in 2007?
Make the answer very short. 1.02. What is the ratio of the Value added (% of GDP) of Antigua and Barbuda in 2005 to that in 2007?
Your response must be concise. 0.8. What is the ratio of the Value added (% of GDP) of Cameroon in 2005 to that in 2007?
Your response must be concise. 1.07. What is the ratio of the Value added (% of GDP) of Seychelles in 2005 to that in 2007?
Your answer should be very brief. 1.02. What is the ratio of the Value added (% of GDP) of Andorra in 2005 to that in 2008?
Provide a succinct answer. 1.02. What is the ratio of the Value added (% of GDP) in Antigua and Barbuda in 2005 to that in 2008?
Offer a very short reply. 0.76. What is the ratio of the Value added (% of GDP) in Cameroon in 2005 to that in 2008?
Give a very brief answer. 1.1. What is the ratio of the Value added (% of GDP) in Seychelles in 2005 to that in 2008?
Your response must be concise. 1.05. What is the ratio of the Value added (% of GDP) of Andorra in 2005 to that in 2009?
Give a very brief answer. 1.1. What is the ratio of the Value added (% of GDP) of Antigua and Barbuda in 2005 to that in 2009?
Provide a short and direct response. 0.75. What is the ratio of the Value added (% of GDP) in Cameroon in 2005 to that in 2009?
Ensure brevity in your answer.  1.07. What is the ratio of the Value added (% of GDP) in Seychelles in 2005 to that in 2009?
Offer a very short reply. 1.17. What is the ratio of the Value added (% of GDP) in Andorra in 2005 to that in 2010?
Your response must be concise. 1.17. What is the ratio of the Value added (% of GDP) in Antigua and Barbuda in 2005 to that in 2010?
Provide a succinct answer. 0.9. What is the ratio of the Value added (% of GDP) of Cameroon in 2005 to that in 2010?
Offer a terse response. 1.07. What is the ratio of the Value added (% of GDP) in Seychelles in 2005 to that in 2010?
Your response must be concise. 1.17. What is the ratio of the Value added (% of GDP) in Andorra in 2005 to that in 2011?
Keep it short and to the point. 1.28. What is the ratio of the Value added (% of GDP) in Cameroon in 2005 to that in 2011?
Give a very brief answer. 1.08. What is the ratio of the Value added (% of GDP) in Seychelles in 2005 to that in 2011?
Make the answer very short. 1.2. What is the ratio of the Value added (% of GDP) of Andorra in 2005 to that in 2012?
Your answer should be compact. 1.44. What is the ratio of the Value added (% of GDP) in Antigua and Barbuda in 2005 to that in 2012?
Offer a very short reply. 1.03. What is the ratio of the Value added (% of GDP) in Cameroon in 2005 to that in 2012?
Your answer should be very brief. 1.06. What is the ratio of the Value added (% of GDP) of Seychelles in 2005 to that in 2012?
Make the answer very short. 1.24. What is the ratio of the Value added (% of GDP) of Andorra in 2006 to that in 2007?
Your response must be concise. 1.04. What is the ratio of the Value added (% of GDP) of Antigua and Barbuda in 2006 to that in 2007?
Your answer should be compact. 1.02. What is the ratio of the Value added (% of GDP) of Cameroon in 2006 to that in 2007?
Ensure brevity in your answer.  1.11. What is the ratio of the Value added (% of GDP) of Seychelles in 2006 to that in 2007?
Make the answer very short. 1.01. What is the ratio of the Value added (% of GDP) in Andorra in 2006 to that in 2008?
Your answer should be very brief. 1.04. What is the ratio of the Value added (% of GDP) of Antigua and Barbuda in 2006 to that in 2008?
Ensure brevity in your answer.  0.96. What is the ratio of the Value added (% of GDP) of Cameroon in 2006 to that in 2008?
Give a very brief answer. 1.15. What is the ratio of the Value added (% of GDP) in Seychelles in 2006 to that in 2008?
Provide a short and direct response. 1.04. What is the ratio of the Value added (% of GDP) in Andorra in 2006 to that in 2009?
Offer a terse response. 1.12. What is the ratio of the Value added (% of GDP) in Antigua and Barbuda in 2006 to that in 2009?
Your answer should be very brief. 0.96. What is the ratio of the Value added (% of GDP) in Cameroon in 2006 to that in 2009?
Provide a short and direct response. 1.11. What is the ratio of the Value added (% of GDP) in Seychelles in 2006 to that in 2009?
Your answer should be very brief. 1.16. What is the ratio of the Value added (% of GDP) of Andorra in 2006 to that in 2010?
Offer a terse response. 1.2. What is the ratio of the Value added (% of GDP) in Antigua and Barbuda in 2006 to that in 2010?
Your response must be concise. 1.14. What is the ratio of the Value added (% of GDP) in Cameroon in 2006 to that in 2010?
Offer a very short reply. 1.11. What is the ratio of the Value added (% of GDP) of Seychelles in 2006 to that in 2010?
Keep it short and to the point. 1.16. What is the ratio of the Value added (% of GDP) of Andorra in 2006 to that in 2011?
Offer a very short reply. 1.31. What is the ratio of the Value added (% of GDP) in Antigua and Barbuda in 2006 to that in 2011?
Provide a succinct answer. 1.28. What is the ratio of the Value added (% of GDP) in Cameroon in 2006 to that in 2011?
Your answer should be compact. 1.12. What is the ratio of the Value added (% of GDP) in Seychelles in 2006 to that in 2011?
Your answer should be very brief. 1.18. What is the ratio of the Value added (% of GDP) of Andorra in 2006 to that in 2012?
Your answer should be very brief. 1.47. What is the ratio of the Value added (% of GDP) of Antigua and Barbuda in 2006 to that in 2012?
Your response must be concise. 1.31. What is the ratio of the Value added (% of GDP) in Cameroon in 2006 to that in 2012?
Provide a short and direct response. 1.1. What is the ratio of the Value added (% of GDP) in Seychelles in 2006 to that in 2012?
Give a very brief answer. 1.22. What is the ratio of the Value added (% of GDP) of Andorra in 2007 to that in 2008?
Ensure brevity in your answer.  1. What is the ratio of the Value added (% of GDP) in Antigua and Barbuda in 2007 to that in 2008?
Your answer should be very brief. 0.94. What is the ratio of the Value added (% of GDP) in Cameroon in 2007 to that in 2008?
Your answer should be compact. 1.03. What is the ratio of the Value added (% of GDP) of Seychelles in 2007 to that in 2008?
Your answer should be very brief. 1.03. What is the ratio of the Value added (% of GDP) of Andorra in 2007 to that in 2009?
Give a very brief answer. 1.08. What is the ratio of the Value added (% of GDP) of Antigua and Barbuda in 2007 to that in 2009?
Make the answer very short. 0.94. What is the ratio of the Value added (% of GDP) of Cameroon in 2007 to that in 2009?
Provide a short and direct response. 1. What is the ratio of the Value added (% of GDP) of Seychelles in 2007 to that in 2009?
Ensure brevity in your answer.  1.15. What is the ratio of the Value added (% of GDP) in Andorra in 2007 to that in 2010?
Offer a terse response. 1.15. What is the ratio of the Value added (% of GDP) of Antigua and Barbuda in 2007 to that in 2010?
Make the answer very short. 1.12. What is the ratio of the Value added (% of GDP) in Cameroon in 2007 to that in 2010?
Keep it short and to the point. 1. What is the ratio of the Value added (% of GDP) of Seychelles in 2007 to that in 2010?
Make the answer very short. 1.15. What is the ratio of the Value added (% of GDP) in Andorra in 2007 to that in 2011?
Your answer should be compact. 1.26. What is the ratio of the Value added (% of GDP) in Antigua and Barbuda in 2007 to that in 2011?
Keep it short and to the point. 1.25. What is the ratio of the Value added (% of GDP) of Cameroon in 2007 to that in 2011?
Keep it short and to the point. 1.01. What is the ratio of the Value added (% of GDP) in Seychelles in 2007 to that in 2011?
Your answer should be compact. 1.17. What is the ratio of the Value added (% of GDP) in Andorra in 2007 to that in 2012?
Make the answer very short. 1.42. What is the ratio of the Value added (% of GDP) of Cameroon in 2007 to that in 2012?
Offer a terse response. 0.99. What is the ratio of the Value added (% of GDP) of Seychelles in 2007 to that in 2012?
Make the answer very short. 1.21. What is the ratio of the Value added (% of GDP) in Andorra in 2008 to that in 2009?
Offer a terse response. 1.08. What is the ratio of the Value added (% of GDP) in Antigua and Barbuda in 2008 to that in 2009?
Offer a terse response. 1. What is the ratio of the Value added (% of GDP) of Cameroon in 2008 to that in 2009?
Make the answer very short. 0.97. What is the ratio of the Value added (% of GDP) in Seychelles in 2008 to that in 2009?
Provide a succinct answer. 1.11. What is the ratio of the Value added (% of GDP) of Andorra in 2008 to that in 2010?
Your answer should be compact. 1.16. What is the ratio of the Value added (% of GDP) of Antigua and Barbuda in 2008 to that in 2010?
Your response must be concise. 1.19. What is the ratio of the Value added (% of GDP) of Cameroon in 2008 to that in 2010?
Keep it short and to the point. 0.97. What is the ratio of the Value added (% of GDP) of Seychelles in 2008 to that in 2010?
Your answer should be compact. 1.11. What is the ratio of the Value added (% of GDP) of Andorra in 2008 to that in 2011?
Keep it short and to the point. 1.26. What is the ratio of the Value added (% of GDP) of Antigua and Barbuda in 2008 to that in 2011?
Provide a short and direct response. 1.33. What is the ratio of the Value added (% of GDP) in Cameroon in 2008 to that in 2011?
Offer a very short reply. 0.98. What is the ratio of the Value added (% of GDP) of Seychelles in 2008 to that in 2011?
Ensure brevity in your answer.  1.14. What is the ratio of the Value added (% of GDP) in Andorra in 2008 to that in 2012?
Provide a succinct answer. 1.42. What is the ratio of the Value added (% of GDP) in Antigua and Barbuda in 2008 to that in 2012?
Make the answer very short. 1.36. What is the ratio of the Value added (% of GDP) of Cameroon in 2008 to that in 2012?
Your answer should be very brief. 0.96. What is the ratio of the Value added (% of GDP) in Seychelles in 2008 to that in 2012?
Provide a succinct answer. 1.18. What is the ratio of the Value added (% of GDP) in Andorra in 2009 to that in 2010?
Offer a terse response. 1.07. What is the ratio of the Value added (% of GDP) of Antigua and Barbuda in 2009 to that in 2010?
Your answer should be very brief. 1.19. What is the ratio of the Value added (% of GDP) of Cameroon in 2009 to that in 2010?
Ensure brevity in your answer.  1. What is the ratio of the Value added (% of GDP) of Andorra in 2009 to that in 2011?
Ensure brevity in your answer.  1.17. What is the ratio of the Value added (% of GDP) in Antigua and Barbuda in 2009 to that in 2011?
Offer a terse response. 1.33. What is the ratio of the Value added (% of GDP) in Cameroon in 2009 to that in 2011?
Provide a short and direct response. 1.01. What is the ratio of the Value added (% of GDP) in Seychelles in 2009 to that in 2011?
Your answer should be compact. 1.02. What is the ratio of the Value added (% of GDP) in Andorra in 2009 to that in 2012?
Your response must be concise. 1.31. What is the ratio of the Value added (% of GDP) of Antigua and Barbuda in 2009 to that in 2012?
Offer a very short reply. 1.37. What is the ratio of the Value added (% of GDP) in Cameroon in 2009 to that in 2012?
Ensure brevity in your answer.  0.99. What is the ratio of the Value added (% of GDP) of Seychelles in 2009 to that in 2012?
Your answer should be compact. 1.06. What is the ratio of the Value added (% of GDP) in Andorra in 2010 to that in 2011?
Give a very brief answer. 1.09. What is the ratio of the Value added (% of GDP) of Antigua and Barbuda in 2010 to that in 2011?
Provide a short and direct response. 1.12. What is the ratio of the Value added (% of GDP) of Cameroon in 2010 to that in 2011?
Give a very brief answer. 1.01. What is the ratio of the Value added (% of GDP) of Seychelles in 2010 to that in 2011?
Your answer should be very brief. 1.02. What is the ratio of the Value added (% of GDP) of Andorra in 2010 to that in 2012?
Offer a terse response. 1.23. What is the ratio of the Value added (% of GDP) in Antigua and Barbuda in 2010 to that in 2012?
Your answer should be very brief. 1.15. What is the ratio of the Value added (% of GDP) of Cameroon in 2010 to that in 2012?
Keep it short and to the point. 0.99. What is the ratio of the Value added (% of GDP) in Seychelles in 2010 to that in 2012?
Give a very brief answer. 1.06. What is the ratio of the Value added (% of GDP) in Andorra in 2011 to that in 2012?
Provide a succinct answer. 1.12. What is the ratio of the Value added (% of GDP) in Antigua and Barbuda in 2011 to that in 2012?
Provide a short and direct response. 1.03. What is the ratio of the Value added (% of GDP) in Cameroon in 2011 to that in 2012?
Provide a short and direct response. 0.98. What is the ratio of the Value added (% of GDP) of Seychelles in 2011 to that in 2012?
Provide a short and direct response. 1.03. What is the difference between the highest and the second highest Value added (% of GDP) in Andorra?
Your response must be concise. 0.3. What is the difference between the highest and the second highest Value added (% of GDP) in Antigua and Barbuda?
Make the answer very short. 0.02. What is the difference between the highest and the second highest Value added (% of GDP) in Cameroon?
Your answer should be compact. 1.22. What is the difference between the highest and the second highest Value added (% of GDP) of Seychelles?
Your answer should be compact. 0.16. What is the difference between the highest and the lowest Value added (% of GDP) in Andorra?
Keep it short and to the point. 5.26. What is the difference between the highest and the lowest Value added (% of GDP) in Antigua and Barbuda?
Offer a very short reply. 6.09. What is the difference between the highest and the lowest Value added (% of GDP) in Cameroon?
Make the answer very short. 4.26. What is the difference between the highest and the lowest Value added (% of GDP) in Seychelles?
Give a very brief answer. 3.14. 